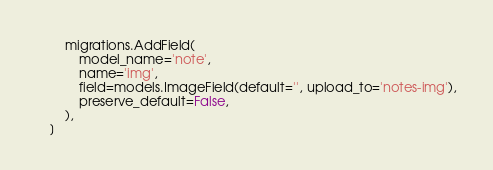<code> <loc_0><loc_0><loc_500><loc_500><_Python_>        migrations.AddField(
            model_name='note',
            name='img',
            field=models.ImageField(default='', upload_to='notes-img'),
            preserve_default=False,
        ),
    ]
</code> 